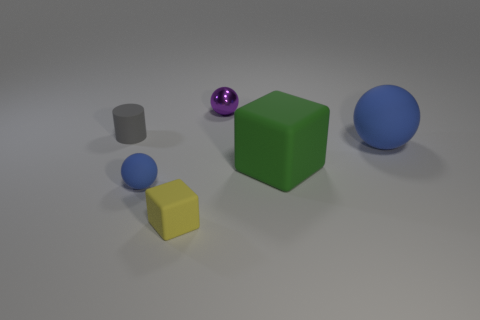Subtract all blue matte balls. How many balls are left? 1 Add 1 small gray matte objects. How many objects exist? 7 Subtract all cylinders. How many objects are left? 5 Add 5 green cylinders. How many green cylinders exist? 5 Subtract 0 red spheres. How many objects are left? 6 Subtract all large green things. Subtract all big yellow metal things. How many objects are left? 5 Add 4 tiny purple metal spheres. How many tiny purple metal spheres are left? 5 